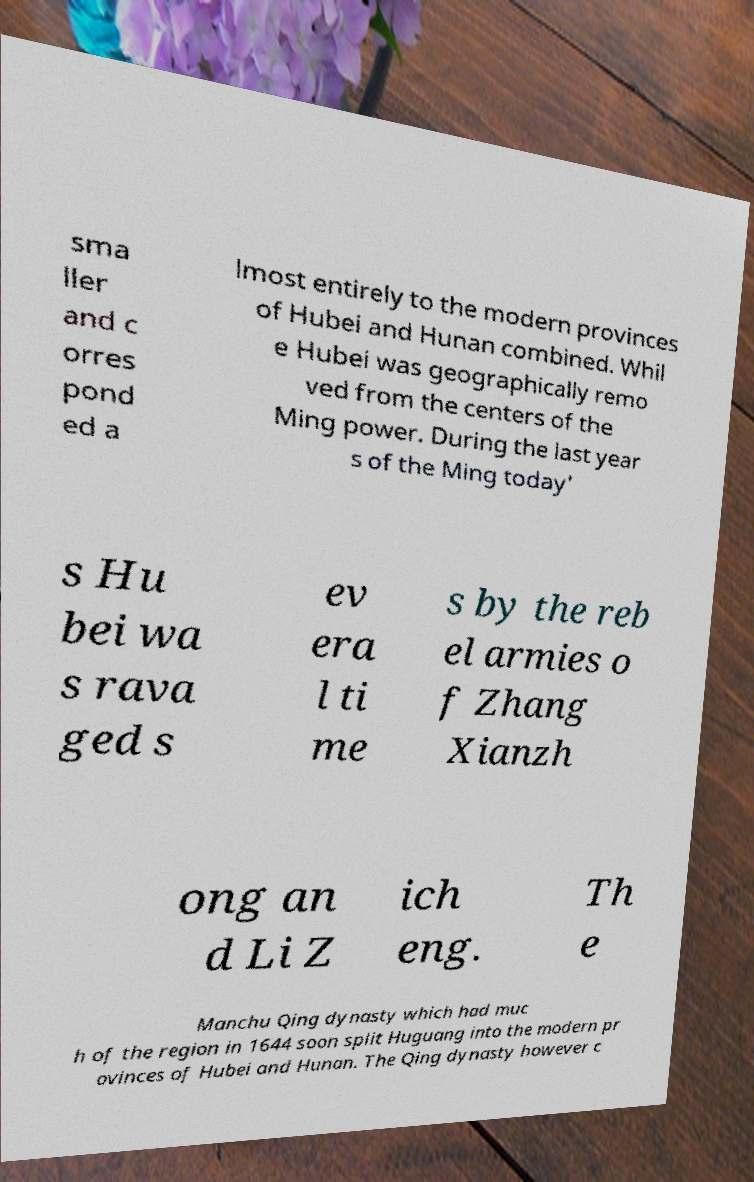Can you read and provide the text displayed in the image?This photo seems to have some interesting text. Can you extract and type it out for me? sma ller and c orres pond ed a lmost entirely to the modern provinces of Hubei and Hunan combined. Whil e Hubei was geographically remo ved from the centers of the Ming power. During the last year s of the Ming today' s Hu bei wa s rava ged s ev era l ti me s by the reb el armies o f Zhang Xianzh ong an d Li Z ich eng. Th e Manchu Qing dynasty which had muc h of the region in 1644 soon split Huguang into the modern pr ovinces of Hubei and Hunan. The Qing dynasty however c 